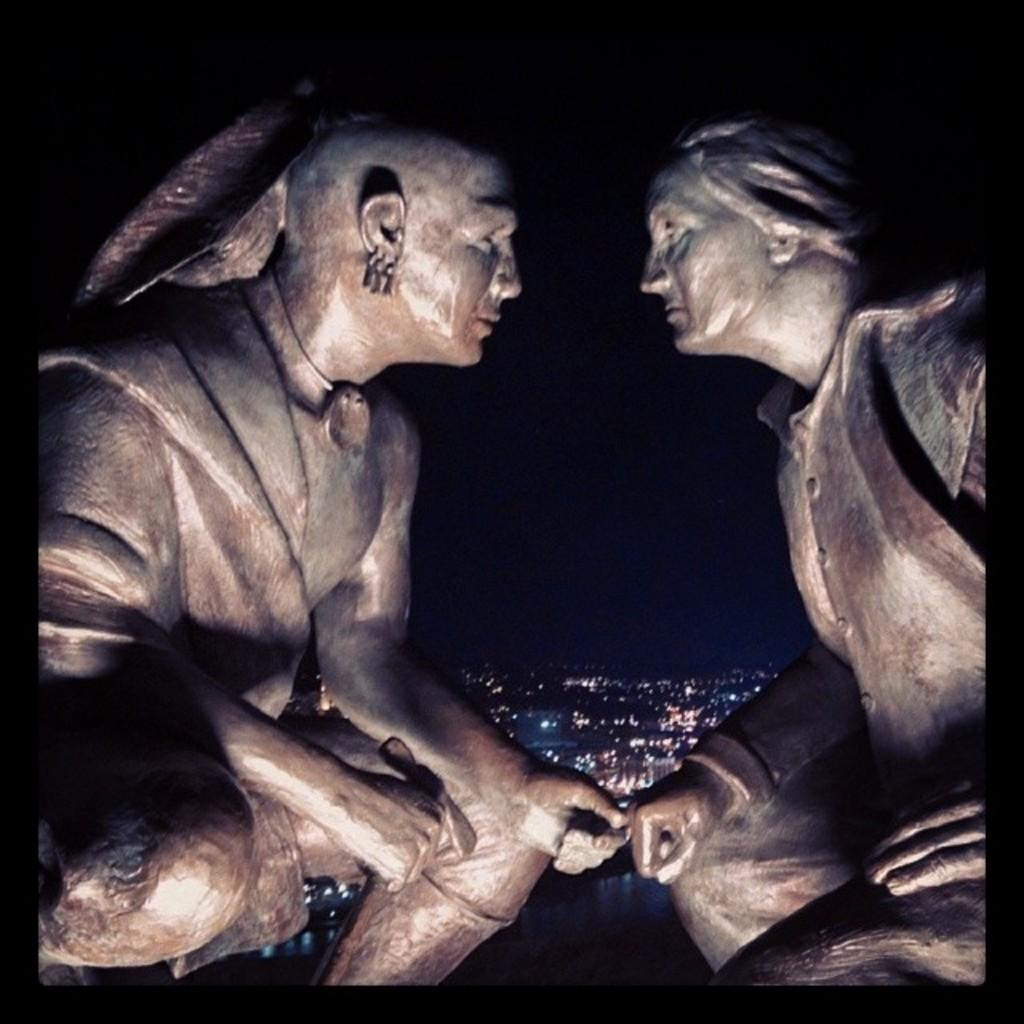What can be seen at the front of the image? There are two sculptures in the front of the image. What can be observed in the background of the image? Multiple lights are visible in the background of the image. How would you describe the overall lighting in the image? The image appears to be slightly dark. What type of vegetable is being used as a waste disposal in the image? There is no vegetable or waste disposal present in the image. 